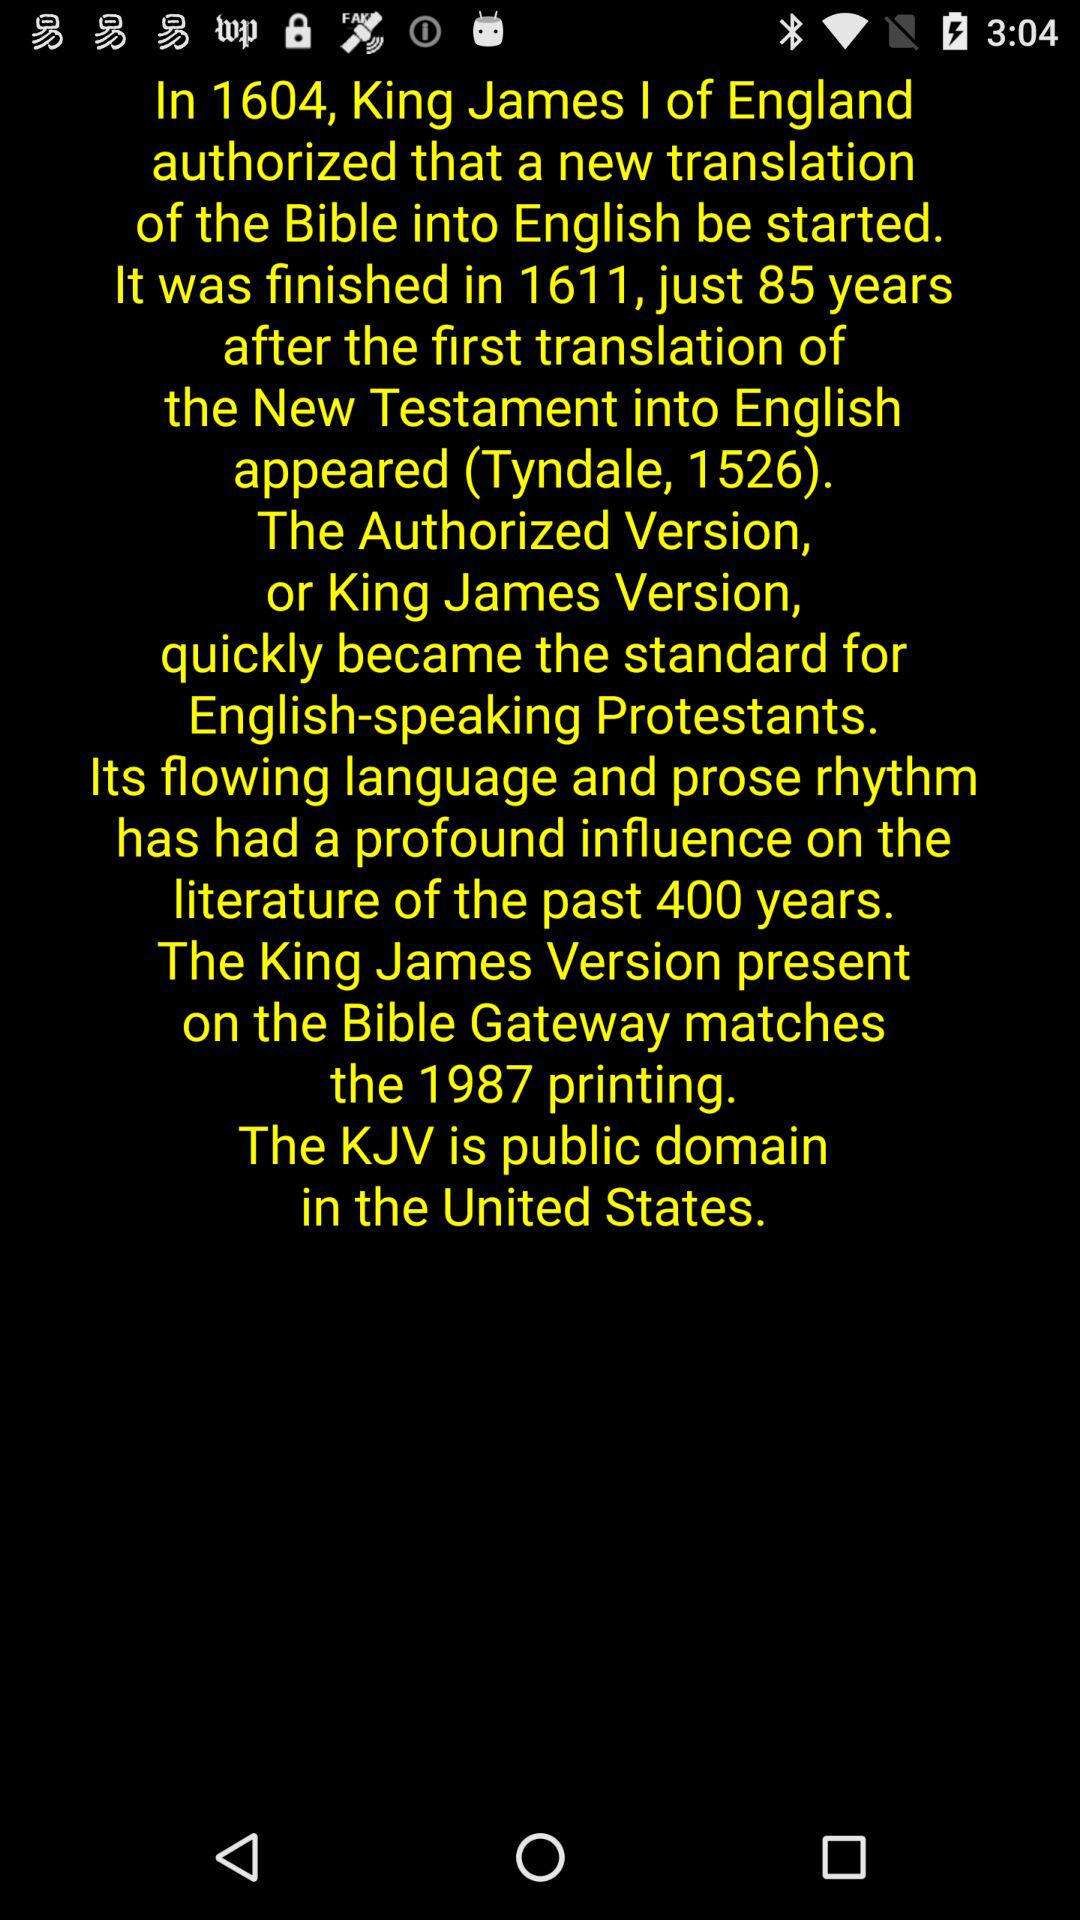Who started the new translation of bible?
When the provided information is insufficient, respond with <no answer>. <no answer> 